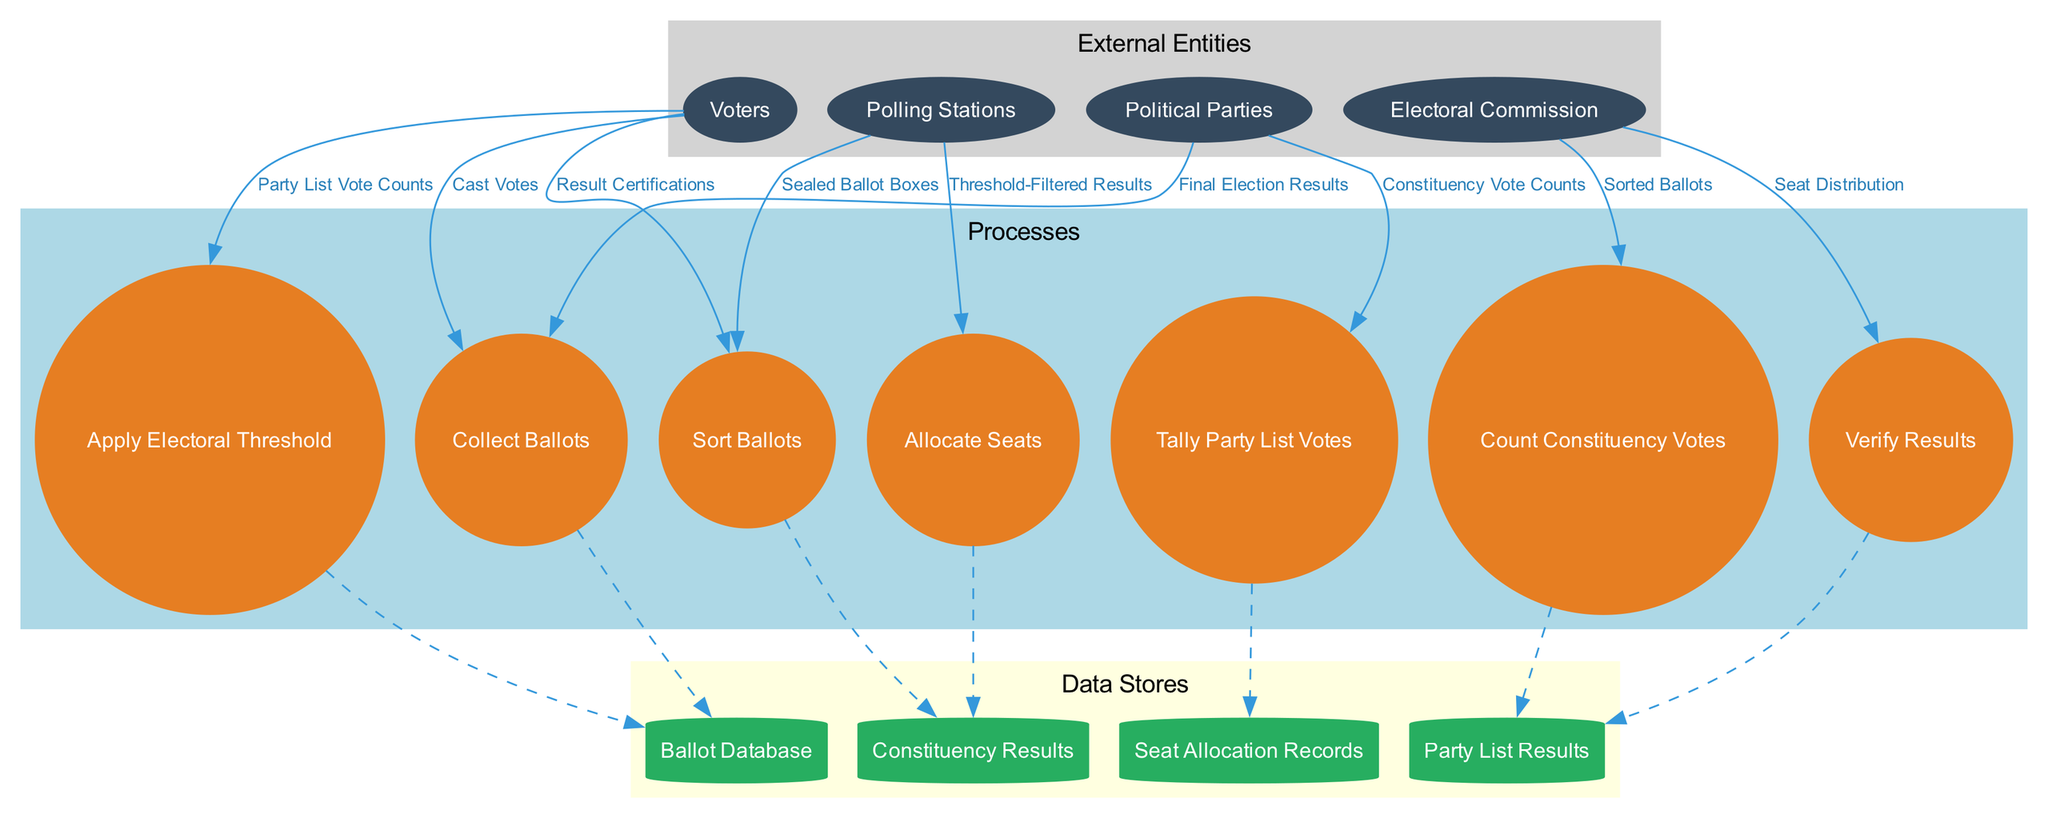What are the external entities in the diagram? The diagram identifies four external entities: Voters, Polling Stations, Electoral Commission, and Political Parties. This can be seen in the "External Entities" section of the diagram.
Answer: Voters, Polling Stations, Electoral Commission, Political Parties How many processes are present in the diagram? The diagram includes seven processes that represent stages in the ballot counting and result tabulation. These processes are listed in the "Processes" section.
Answer: Seven What data flows from "Polling Stations" to "Collect Ballots"? The data flow from "Polling Stations" to "Collect Ballots" is labeled as "Sealed Ballot Boxes," indicating the transfer of ballot materials from polling locations to the counting process.
Answer: Sealed Ballot Boxes Which process follows "Sort Ballots"? The next process after "Sort Ballots" is "Count Constituency Votes," establishing the sequence in the electoral process where sorted ballots are counted within constituencies.
Answer: Count Constituency Votes What is stored in the "Ballot Database"? The "Ballot Database" stores the ballot information collected during the voting process, which is part of the overall data management for results tabulation.
Answer: Ballot information What types of results are verified in the diagram? The "Verify Results" process encompasses the examination of both "Constituency Results" and "Party List Results" before final certifications are made. This is indicated by the connections from each results store to the verification process.
Answer: Constituency Results, Party List Results How many data stores are modeled in the diagram? The diagram illustrates four data stores that are essential for maintaining the results and tracking data flow throughout the electoral processes.
Answer: Four What is the purpose of the "Apply Electoral Threshold" process? The "Apply Electoral Threshold" process serves to filter the party list votes, determining which parties meet the necessary conditions for representation based on the established electoral threshold.
Answer: Filter party list votes Which entity receives the "Final Election Results"? The "Electoral Commission" is the entity that receives the "Final Election Results," as evidenced by the final data flow leading to this external entity, signifying the completion and official reporting of election outcomes.
Answer: Electoral Commission 